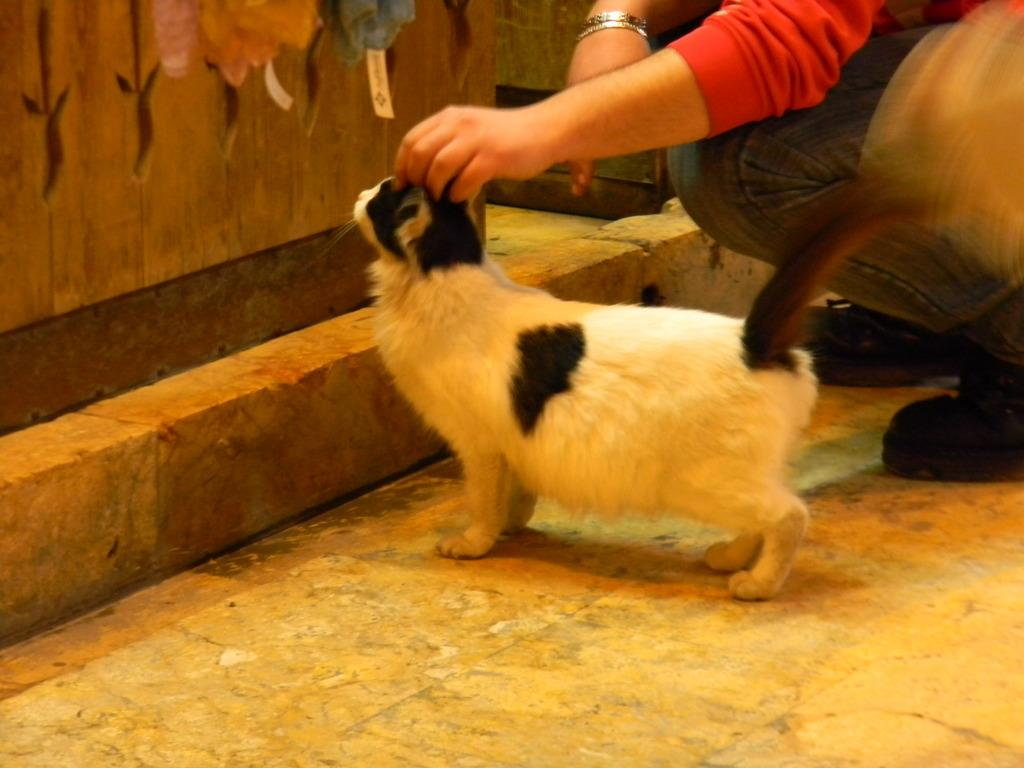What type of animal is in the image? There is a cat in the image. Where is the cat located? The cat is on a surface in the image. Who else is present in the image? There is a person in the image. What type of material is visible in the image? There is a wooden wall in the image. What color is the sweater the cat is wearing in the image? There is no sweater present in the image, and the cat is not wearing any clothing. 